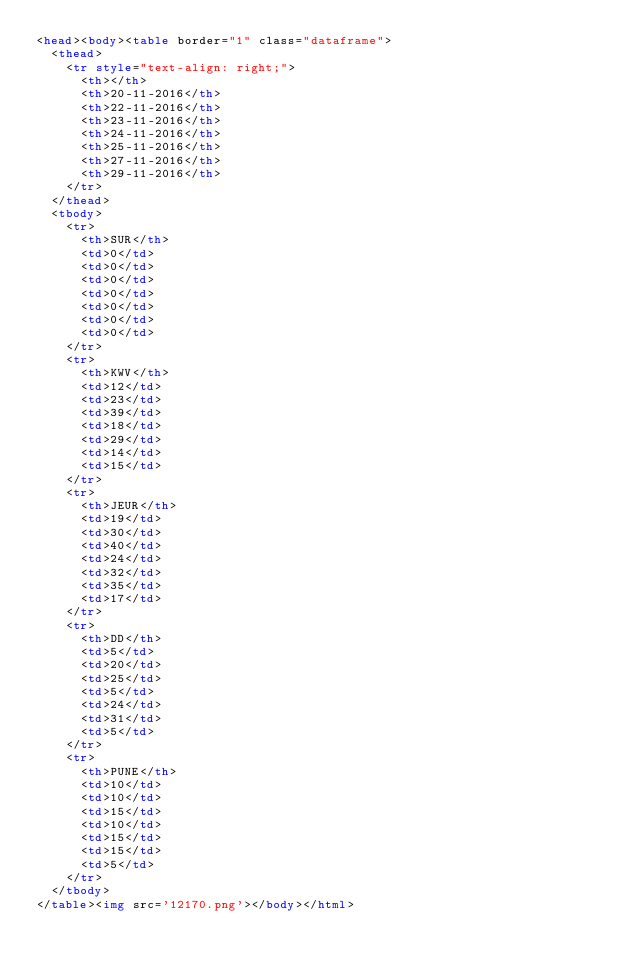<code> <loc_0><loc_0><loc_500><loc_500><_HTML_><head><body><table border="1" class="dataframe">
  <thead>
    <tr style="text-align: right;">
      <th></th>
      <th>20-11-2016</th>
      <th>22-11-2016</th>
      <th>23-11-2016</th>
      <th>24-11-2016</th>
      <th>25-11-2016</th>
      <th>27-11-2016</th>
      <th>29-11-2016</th>
    </tr>
  </thead>
  <tbody>
    <tr>
      <th>SUR</th>
      <td>0</td>
      <td>0</td>
      <td>0</td>
      <td>0</td>
      <td>0</td>
      <td>0</td>
      <td>0</td>
    </tr>
    <tr>
      <th>KWV</th>
      <td>12</td>
      <td>23</td>
      <td>39</td>
      <td>18</td>
      <td>29</td>
      <td>14</td>
      <td>15</td>
    </tr>
    <tr>
      <th>JEUR</th>
      <td>19</td>
      <td>30</td>
      <td>40</td>
      <td>24</td>
      <td>32</td>
      <td>35</td>
      <td>17</td>
    </tr>
    <tr>
      <th>DD</th>
      <td>5</td>
      <td>20</td>
      <td>25</td>
      <td>5</td>
      <td>24</td>
      <td>31</td>
      <td>5</td>
    </tr>
    <tr>
      <th>PUNE</th>
      <td>10</td>
      <td>10</td>
      <td>15</td>
      <td>10</td>
      <td>15</td>
      <td>15</td>
      <td>5</td>
    </tr>
  </tbody>
</table><img src='12170.png'></body></html></code> 